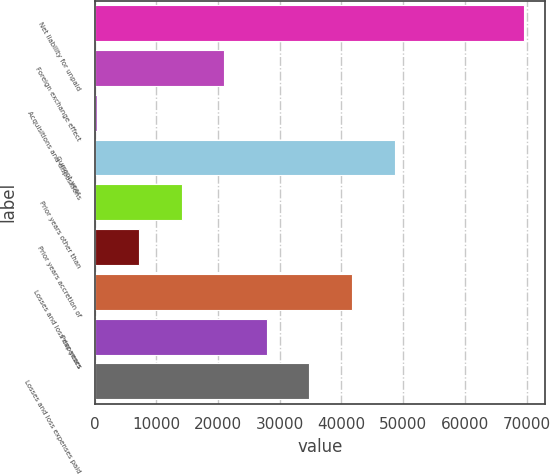<chart> <loc_0><loc_0><loc_500><loc_500><bar_chart><fcel>Net liability for unpaid<fcel>Foreign exchange effect<fcel>Acquisitions and dispositions<fcel>Current year<fcel>Prior years other than<fcel>Prior years accretion of<fcel>Losses and loss expenses<fcel>Prior years<fcel>Losses and loss expenses paid<nl><fcel>69527.1<fcel>21008.3<fcel>317<fcel>48596.7<fcel>14111.2<fcel>7214.1<fcel>41699.6<fcel>27905.4<fcel>34802.5<nl></chart> 